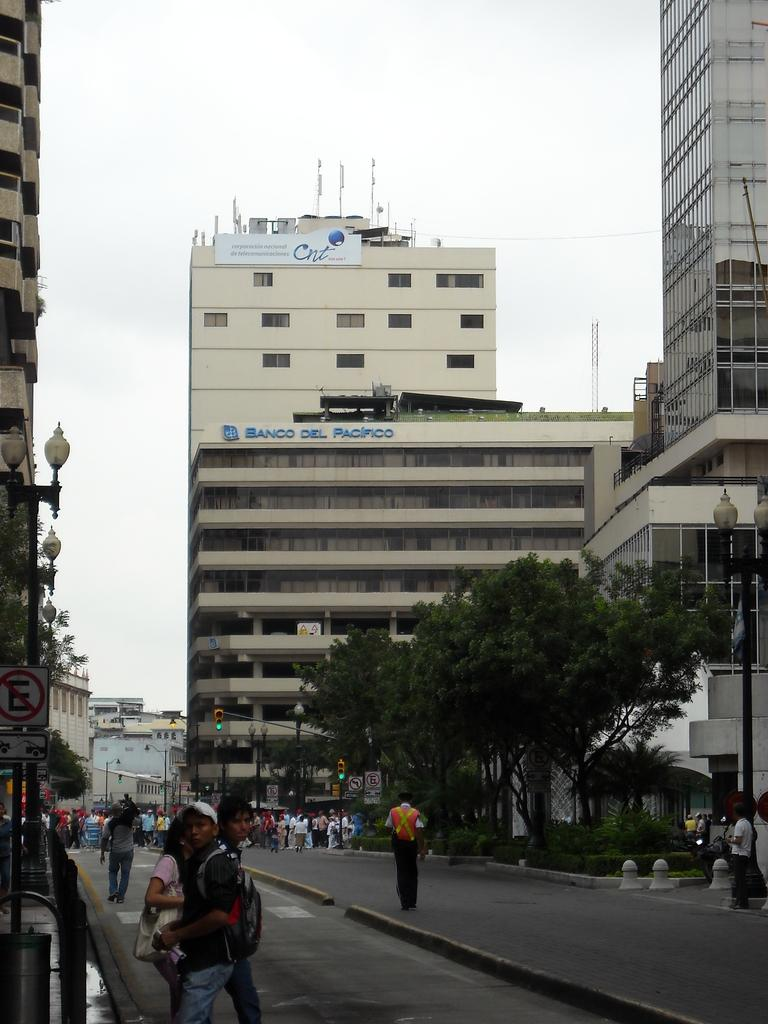<image>
Create a compact narrative representing the image presented. People walking in front of a building named Banco Del Pacifico. 